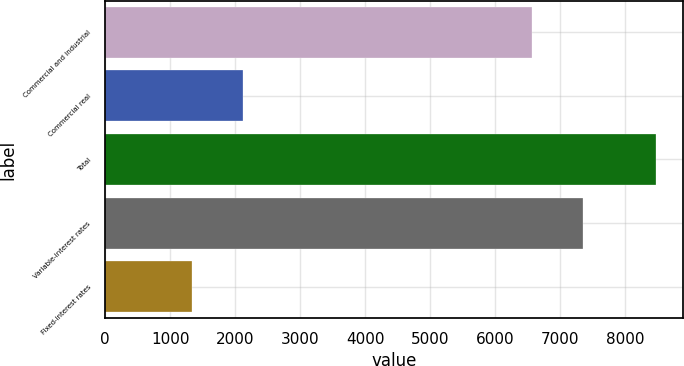Convert chart. <chart><loc_0><loc_0><loc_500><loc_500><bar_chart><fcel>Commercial and industrial<fcel>Commercial real<fcel>Total<fcel>Variable-interest rates<fcel>Fixed-interest rates<nl><fcel>6557<fcel>2122.2<fcel>8467<fcel>7350.1<fcel>1329.1<nl></chart> 